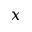<formula> <loc_0><loc_0><loc_500><loc_500>x</formula> 